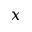<formula> <loc_0><loc_0><loc_500><loc_500>x</formula> 